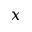<formula> <loc_0><loc_0><loc_500><loc_500>x</formula> 